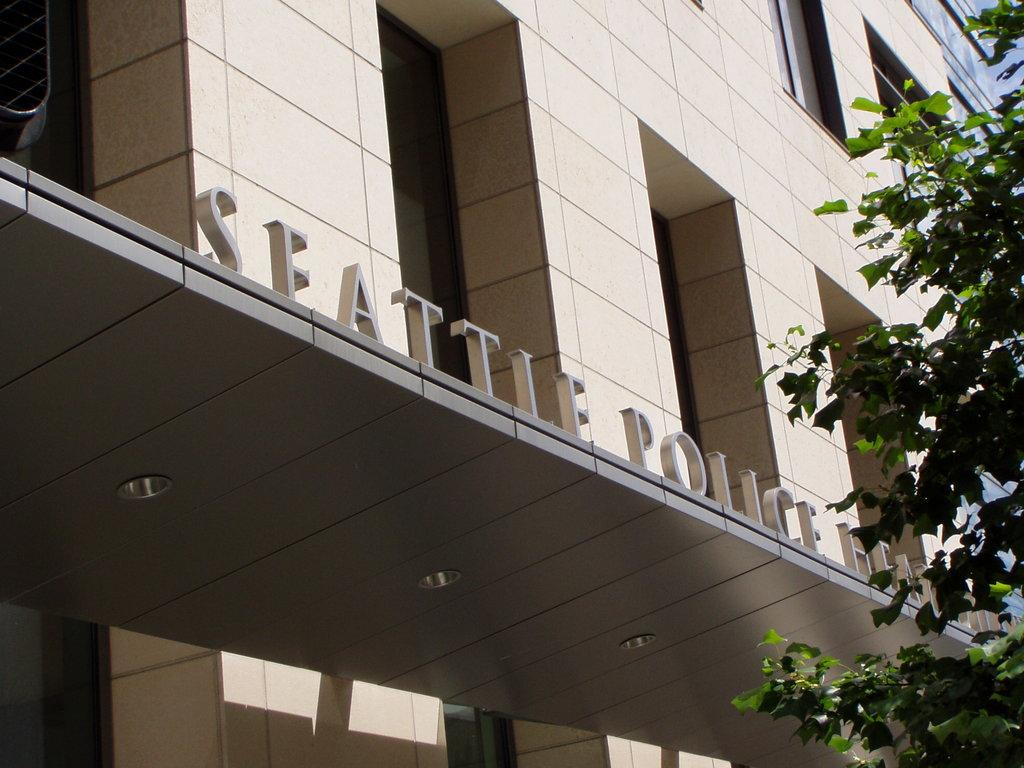What is located on the right side of the image in the foreground? There is a tree in the foreground of the image, on the right side. What can be seen in the background of the image? There is a building in the background of the image. What is written or displayed on the building? There is a name on the building. Are there any additional features associated with the building? Yes, there are lights associated with the building. Can you see any coal being transported by the river in the image? There is no river present in the image, and therefore no coal transportation can be observed. 